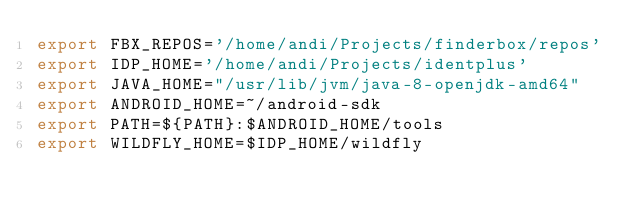Convert code to text. <code><loc_0><loc_0><loc_500><loc_500><_Bash_>export FBX_REPOS='/home/andi/Projects/finderbox/repos'
export IDP_HOME='/home/andi/Projects/identplus'
export JAVA_HOME="/usr/lib/jvm/java-8-openjdk-amd64"
export ANDROID_HOME=~/android-sdk
export PATH=${PATH}:$ANDROID_HOME/tools
export WILDFLY_HOME=$IDP_HOME/wildfly</code> 